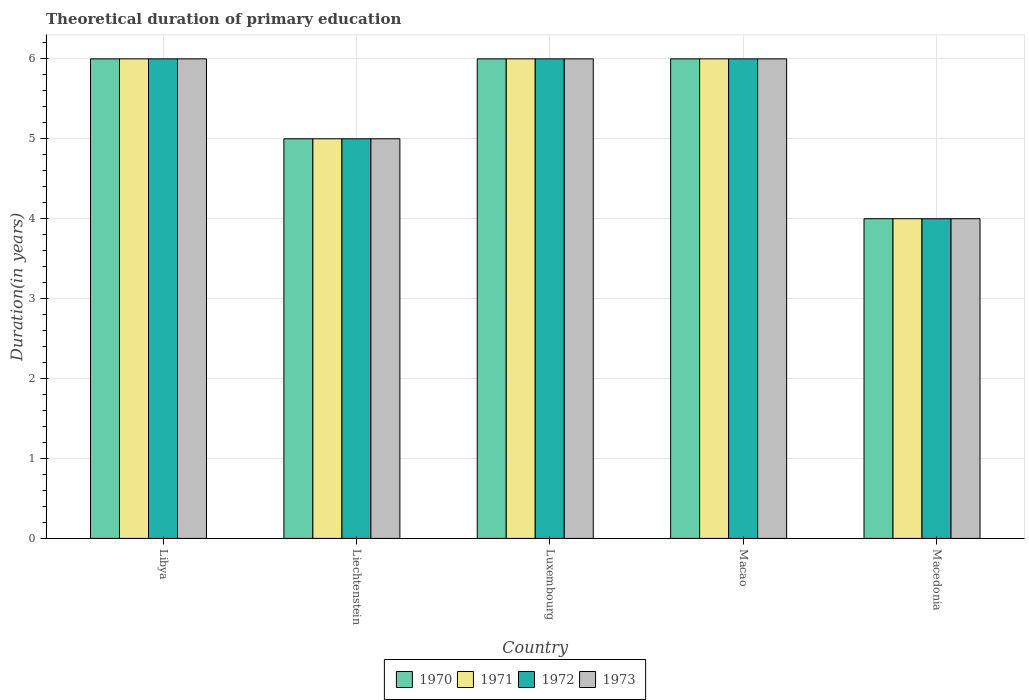How many different coloured bars are there?
Offer a terse response. 4. What is the label of the 4th group of bars from the left?
Your response must be concise. Macao. In how many cases, is the number of bars for a given country not equal to the number of legend labels?
Keep it short and to the point. 0. Across all countries, what is the maximum total theoretical duration of primary education in 1972?
Offer a terse response. 6. In which country was the total theoretical duration of primary education in 1971 maximum?
Ensure brevity in your answer.  Libya. In which country was the total theoretical duration of primary education in 1971 minimum?
Keep it short and to the point. Macedonia. What is the total total theoretical duration of primary education in 1971 in the graph?
Your response must be concise. 27. What is the difference between the total theoretical duration of primary education in 1973 in Macedonia and the total theoretical duration of primary education in 1970 in Macao?
Give a very brief answer. -2. What is the ratio of the total theoretical duration of primary education in 1972 in Luxembourg to that in Macedonia?
Your answer should be compact. 1.5. Is the difference between the total theoretical duration of primary education in 1972 in Macao and Macedonia greater than the difference between the total theoretical duration of primary education in 1971 in Macao and Macedonia?
Provide a short and direct response. No. What is the difference between the highest and the lowest total theoretical duration of primary education in 1971?
Offer a terse response. 2. What does the 1st bar from the right in Macedonia represents?
Give a very brief answer. 1973. How many bars are there?
Offer a terse response. 20. Are all the bars in the graph horizontal?
Offer a very short reply. No. Are the values on the major ticks of Y-axis written in scientific E-notation?
Your answer should be very brief. No. Where does the legend appear in the graph?
Your answer should be compact. Bottom center. How many legend labels are there?
Keep it short and to the point. 4. What is the title of the graph?
Provide a short and direct response. Theoretical duration of primary education. What is the label or title of the X-axis?
Make the answer very short. Country. What is the label or title of the Y-axis?
Offer a very short reply. Duration(in years). What is the Duration(in years) in 1971 in Libya?
Provide a short and direct response. 6. What is the Duration(in years) in 1972 in Libya?
Provide a short and direct response. 6. What is the Duration(in years) in 1970 in Liechtenstein?
Make the answer very short. 5. What is the Duration(in years) of 1971 in Liechtenstein?
Ensure brevity in your answer.  5. What is the Duration(in years) in 1972 in Liechtenstein?
Provide a short and direct response. 5. What is the Duration(in years) in 1970 in Luxembourg?
Make the answer very short. 6. What is the Duration(in years) in 1971 in Luxembourg?
Offer a terse response. 6. What is the Duration(in years) in 1970 in Macao?
Your answer should be compact. 6. What is the Duration(in years) of 1972 in Macao?
Give a very brief answer. 6. What is the Duration(in years) of 1973 in Macao?
Offer a very short reply. 6. What is the Duration(in years) of 1972 in Macedonia?
Offer a terse response. 4. What is the Duration(in years) of 1973 in Macedonia?
Keep it short and to the point. 4. Across all countries, what is the maximum Duration(in years) of 1970?
Provide a succinct answer. 6. Across all countries, what is the maximum Duration(in years) in 1973?
Offer a very short reply. 6. Across all countries, what is the minimum Duration(in years) in 1970?
Provide a short and direct response. 4. Across all countries, what is the minimum Duration(in years) of 1973?
Your answer should be compact. 4. What is the difference between the Duration(in years) of 1971 in Libya and that in Liechtenstein?
Provide a short and direct response. 1. What is the difference between the Duration(in years) in 1973 in Libya and that in Liechtenstein?
Give a very brief answer. 1. What is the difference between the Duration(in years) of 1972 in Libya and that in Luxembourg?
Offer a very short reply. 0. What is the difference between the Duration(in years) of 1973 in Libya and that in Luxembourg?
Make the answer very short. 0. What is the difference between the Duration(in years) in 1971 in Libya and that in Macao?
Your answer should be very brief. 0. What is the difference between the Duration(in years) in 1972 in Libya and that in Macao?
Your answer should be compact. 0. What is the difference between the Duration(in years) of 1973 in Libya and that in Macao?
Your answer should be very brief. 0. What is the difference between the Duration(in years) of 1971 in Libya and that in Macedonia?
Your response must be concise. 2. What is the difference between the Duration(in years) in 1972 in Libya and that in Macedonia?
Provide a succinct answer. 2. What is the difference between the Duration(in years) of 1970 in Liechtenstein and that in Luxembourg?
Keep it short and to the point. -1. What is the difference between the Duration(in years) of 1972 in Liechtenstein and that in Luxembourg?
Keep it short and to the point. -1. What is the difference between the Duration(in years) in 1973 in Liechtenstein and that in Luxembourg?
Your response must be concise. -1. What is the difference between the Duration(in years) of 1971 in Liechtenstein and that in Macao?
Give a very brief answer. -1. What is the difference between the Duration(in years) of 1970 in Liechtenstein and that in Macedonia?
Give a very brief answer. 1. What is the difference between the Duration(in years) of 1972 in Liechtenstein and that in Macedonia?
Offer a terse response. 1. What is the difference between the Duration(in years) in 1973 in Liechtenstein and that in Macedonia?
Offer a terse response. 1. What is the difference between the Duration(in years) of 1971 in Luxembourg and that in Macao?
Ensure brevity in your answer.  0. What is the difference between the Duration(in years) in 1972 in Luxembourg and that in Macao?
Give a very brief answer. 0. What is the difference between the Duration(in years) of 1971 in Luxembourg and that in Macedonia?
Provide a short and direct response. 2. What is the difference between the Duration(in years) of 1972 in Luxembourg and that in Macedonia?
Make the answer very short. 2. What is the difference between the Duration(in years) in 1973 in Luxembourg and that in Macedonia?
Offer a very short reply. 2. What is the difference between the Duration(in years) in 1972 in Macao and that in Macedonia?
Your answer should be very brief. 2. What is the difference between the Duration(in years) of 1970 in Libya and the Duration(in years) of 1972 in Liechtenstein?
Ensure brevity in your answer.  1. What is the difference between the Duration(in years) of 1970 in Libya and the Duration(in years) of 1973 in Liechtenstein?
Provide a short and direct response. 1. What is the difference between the Duration(in years) of 1971 in Libya and the Duration(in years) of 1972 in Liechtenstein?
Keep it short and to the point. 1. What is the difference between the Duration(in years) in 1972 in Libya and the Duration(in years) in 1973 in Liechtenstein?
Give a very brief answer. 1. What is the difference between the Duration(in years) of 1970 in Libya and the Duration(in years) of 1971 in Luxembourg?
Your answer should be very brief. 0. What is the difference between the Duration(in years) of 1970 in Libya and the Duration(in years) of 1972 in Luxembourg?
Your answer should be compact. 0. What is the difference between the Duration(in years) of 1971 in Libya and the Duration(in years) of 1972 in Luxembourg?
Your answer should be compact. 0. What is the difference between the Duration(in years) in 1971 in Libya and the Duration(in years) in 1973 in Luxembourg?
Provide a succinct answer. 0. What is the difference between the Duration(in years) in 1972 in Libya and the Duration(in years) in 1973 in Luxembourg?
Offer a very short reply. 0. What is the difference between the Duration(in years) in 1970 in Libya and the Duration(in years) in 1972 in Macao?
Provide a short and direct response. 0. What is the difference between the Duration(in years) of 1970 in Libya and the Duration(in years) of 1973 in Macao?
Your response must be concise. 0. What is the difference between the Duration(in years) of 1971 in Libya and the Duration(in years) of 1972 in Macao?
Provide a succinct answer. 0. What is the difference between the Duration(in years) of 1971 in Libya and the Duration(in years) of 1973 in Macao?
Ensure brevity in your answer.  0. What is the difference between the Duration(in years) of 1970 in Libya and the Duration(in years) of 1971 in Macedonia?
Give a very brief answer. 2. What is the difference between the Duration(in years) in 1970 in Libya and the Duration(in years) in 1973 in Macedonia?
Provide a short and direct response. 2. What is the difference between the Duration(in years) in 1972 in Libya and the Duration(in years) in 1973 in Macedonia?
Offer a very short reply. 2. What is the difference between the Duration(in years) in 1970 in Liechtenstein and the Duration(in years) in 1971 in Luxembourg?
Keep it short and to the point. -1. What is the difference between the Duration(in years) of 1970 in Liechtenstein and the Duration(in years) of 1972 in Luxembourg?
Your response must be concise. -1. What is the difference between the Duration(in years) of 1971 in Liechtenstein and the Duration(in years) of 1973 in Luxembourg?
Your response must be concise. -1. What is the difference between the Duration(in years) of 1972 in Liechtenstein and the Duration(in years) of 1973 in Luxembourg?
Offer a terse response. -1. What is the difference between the Duration(in years) of 1970 in Liechtenstein and the Duration(in years) of 1971 in Macao?
Give a very brief answer. -1. What is the difference between the Duration(in years) in 1970 in Liechtenstein and the Duration(in years) in 1972 in Macao?
Provide a short and direct response. -1. What is the difference between the Duration(in years) of 1971 in Liechtenstein and the Duration(in years) of 1972 in Macao?
Your answer should be very brief. -1. What is the difference between the Duration(in years) of 1972 in Liechtenstein and the Duration(in years) of 1973 in Macao?
Provide a succinct answer. -1. What is the difference between the Duration(in years) of 1970 in Liechtenstein and the Duration(in years) of 1971 in Macedonia?
Ensure brevity in your answer.  1. What is the difference between the Duration(in years) of 1971 in Liechtenstein and the Duration(in years) of 1972 in Macedonia?
Keep it short and to the point. 1. What is the difference between the Duration(in years) of 1971 in Liechtenstein and the Duration(in years) of 1973 in Macedonia?
Give a very brief answer. 1. What is the difference between the Duration(in years) of 1972 in Liechtenstein and the Duration(in years) of 1973 in Macedonia?
Give a very brief answer. 1. What is the difference between the Duration(in years) in 1970 in Luxembourg and the Duration(in years) in 1971 in Macao?
Your response must be concise. 0. What is the difference between the Duration(in years) in 1970 in Luxembourg and the Duration(in years) in 1973 in Macao?
Your response must be concise. 0. What is the difference between the Duration(in years) of 1971 in Luxembourg and the Duration(in years) of 1972 in Macao?
Give a very brief answer. 0. What is the difference between the Duration(in years) of 1970 in Luxembourg and the Duration(in years) of 1972 in Macedonia?
Your answer should be very brief. 2. What is the difference between the Duration(in years) of 1970 in Luxembourg and the Duration(in years) of 1973 in Macedonia?
Keep it short and to the point. 2. What is the difference between the Duration(in years) of 1971 in Luxembourg and the Duration(in years) of 1972 in Macedonia?
Ensure brevity in your answer.  2. What is the difference between the Duration(in years) of 1970 in Macao and the Duration(in years) of 1971 in Macedonia?
Keep it short and to the point. 2. What is the difference between the Duration(in years) of 1970 in Macao and the Duration(in years) of 1972 in Macedonia?
Offer a very short reply. 2. What is the difference between the Duration(in years) in 1970 in Macao and the Duration(in years) in 1973 in Macedonia?
Your answer should be compact. 2. What is the difference between the Duration(in years) of 1971 in Macao and the Duration(in years) of 1972 in Macedonia?
Your answer should be very brief. 2. What is the difference between the Duration(in years) in 1972 in Macao and the Duration(in years) in 1973 in Macedonia?
Your response must be concise. 2. What is the average Duration(in years) of 1972 per country?
Make the answer very short. 5.4. What is the difference between the Duration(in years) of 1970 and Duration(in years) of 1971 in Libya?
Keep it short and to the point. 0. What is the difference between the Duration(in years) of 1971 and Duration(in years) of 1972 in Libya?
Your answer should be very brief. 0. What is the difference between the Duration(in years) of 1972 and Duration(in years) of 1973 in Libya?
Make the answer very short. 0. What is the difference between the Duration(in years) of 1970 and Duration(in years) of 1971 in Liechtenstein?
Give a very brief answer. 0. What is the difference between the Duration(in years) of 1970 and Duration(in years) of 1972 in Liechtenstein?
Make the answer very short. 0. What is the difference between the Duration(in years) in 1972 and Duration(in years) in 1973 in Liechtenstein?
Offer a very short reply. 0. What is the difference between the Duration(in years) in 1970 and Duration(in years) in 1971 in Luxembourg?
Your answer should be very brief. 0. What is the difference between the Duration(in years) in 1970 and Duration(in years) in 1972 in Luxembourg?
Offer a terse response. 0. What is the difference between the Duration(in years) in 1971 and Duration(in years) in 1973 in Luxembourg?
Keep it short and to the point. 0. What is the difference between the Duration(in years) in 1972 and Duration(in years) in 1973 in Luxembourg?
Provide a succinct answer. 0. What is the difference between the Duration(in years) of 1970 and Duration(in years) of 1971 in Macao?
Your answer should be very brief. 0. What is the difference between the Duration(in years) in 1970 and Duration(in years) in 1972 in Macao?
Make the answer very short. 0. What is the difference between the Duration(in years) in 1971 and Duration(in years) in 1973 in Macao?
Offer a very short reply. 0. What is the difference between the Duration(in years) in 1970 and Duration(in years) in 1971 in Macedonia?
Keep it short and to the point. 0. What is the difference between the Duration(in years) in 1970 and Duration(in years) in 1972 in Macedonia?
Provide a succinct answer. 0. What is the ratio of the Duration(in years) in 1970 in Libya to that in Liechtenstein?
Give a very brief answer. 1.2. What is the ratio of the Duration(in years) of 1971 in Libya to that in Liechtenstein?
Offer a terse response. 1.2. What is the ratio of the Duration(in years) of 1973 in Libya to that in Liechtenstein?
Provide a succinct answer. 1.2. What is the ratio of the Duration(in years) of 1970 in Libya to that in Luxembourg?
Keep it short and to the point. 1. What is the ratio of the Duration(in years) in 1971 in Libya to that in Luxembourg?
Your answer should be very brief. 1. What is the ratio of the Duration(in years) in 1973 in Libya to that in Luxembourg?
Offer a very short reply. 1. What is the ratio of the Duration(in years) of 1972 in Libya to that in Macedonia?
Provide a succinct answer. 1.5. What is the ratio of the Duration(in years) of 1970 in Liechtenstein to that in Luxembourg?
Your response must be concise. 0.83. What is the ratio of the Duration(in years) in 1971 in Liechtenstein to that in Luxembourg?
Give a very brief answer. 0.83. What is the ratio of the Duration(in years) of 1970 in Liechtenstein to that in Macao?
Make the answer very short. 0.83. What is the ratio of the Duration(in years) in 1972 in Liechtenstein to that in Macao?
Your answer should be compact. 0.83. What is the ratio of the Duration(in years) in 1971 in Liechtenstein to that in Macedonia?
Your response must be concise. 1.25. What is the ratio of the Duration(in years) of 1973 in Liechtenstein to that in Macedonia?
Give a very brief answer. 1.25. What is the ratio of the Duration(in years) of 1970 in Luxembourg to that in Macao?
Ensure brevity in your answer.  1. What is the ratio of the Duration(in years) in 1972 in Luxembourg to that in Macao?
Ensure brevity in your answer.  1. What is the ratio of the Duration(in years) in 1972 in Luxembourg to that in Macedonia?
Provide a succinct answer. 1.5. What is the ratio of the Duration(in years) of 1973 in Luxembourg to that in Macedonia?
Offer a terse response. 1.5. What is the ratio of the Duration(in years) in 1971 in Macao to that in Macedonia?
Your response must be concise. 1.5. What is the ratio of the Duration(in years) in 1973 in Macao to that in Macedonia?
Offer a terse response. 1.5. What is the difference between the highest and the second highest Duration(in years) in 1970?
Your answer should be compact. 0. What is the difference between the highest and the lowest Duration(in years) of 1972?
Offer a terse response. 2. What is the difference between the highest and the lowest Duration(in years) of 1973?
Your response must be concise. 2. 